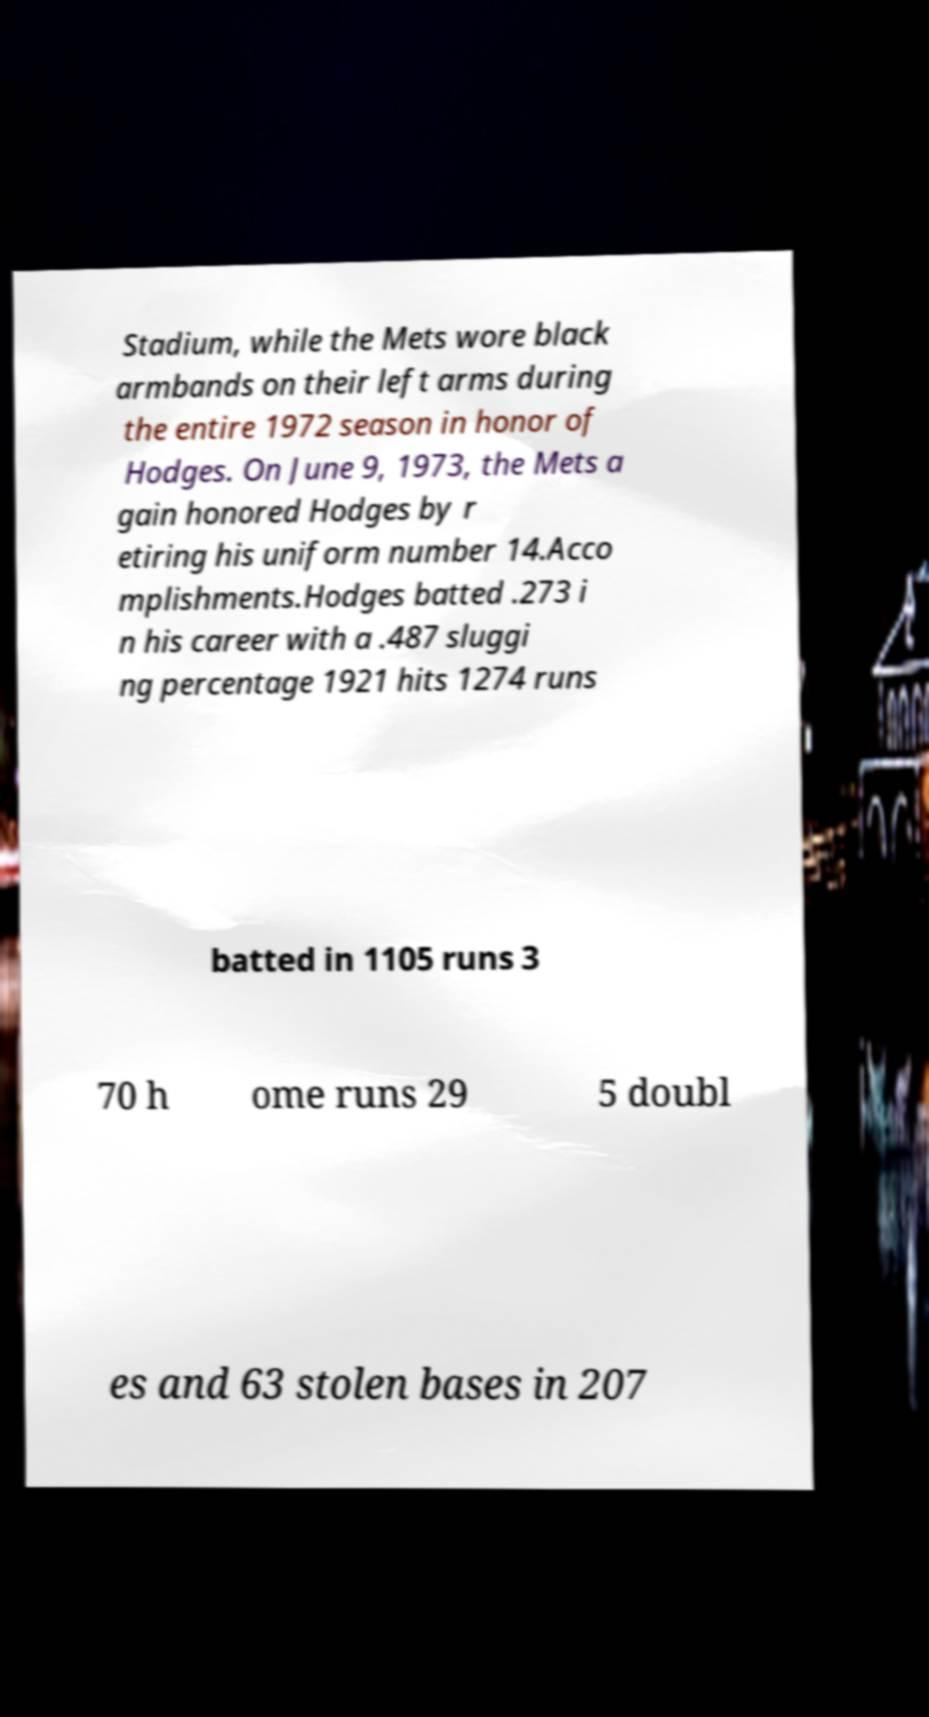What messages or text are displayed in this image? I need them in a readable, typed format. Stadium, while the Mets wore black armbands on their left arms during the entire 1972 season in honor of Hodges. On June 9, 1973, the Mets a gain honored Hodges by r etiring his uniform number 14.Acco mplishments.Hodges batted .273 i n his career with a .487 sluggi ng percentage 1921 hits 1274 runs batted in 1105 runs 3 70 h ome runs 29 5 doubl es and 63 stolen bases in 207 